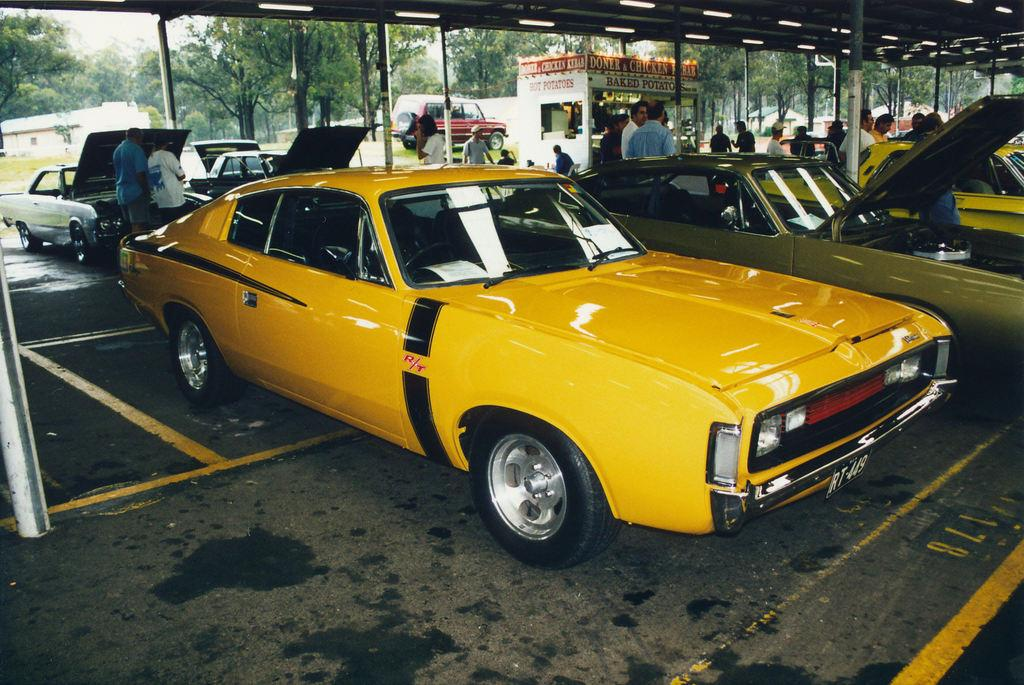Provide a one-sentence caption for the provided image. Yellow car with license plate RT449 at an auto show. 